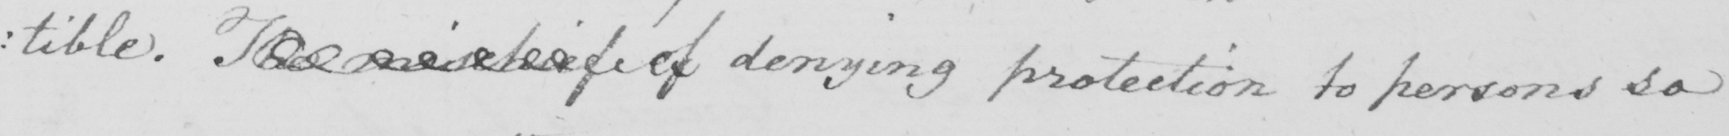Can you read and transcribe this handwriting? : tible . The mischief of denying protection to persons so 